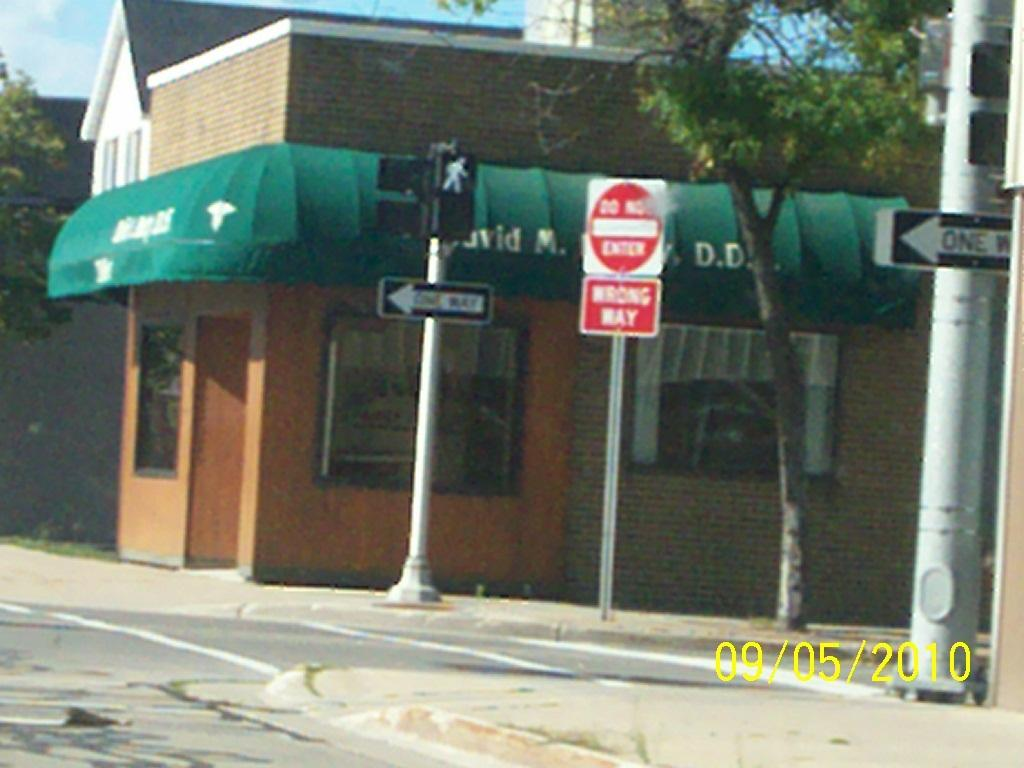What type of structures can be seen in the image? There are houses in the image. What feature is common to many of the houses in the image? There are windows in the image. What are the poles likely used for in the image? The poles are likely used for supporting signboards or other objects in the image. What type of information might be conveyed by the signboards in the image? The signboards in the image might convey information about businesses, directions, or other notices. What is written on the board with text in the image? The specific text on the board cannot be determined from the image. What type of vegetation is present in the image? There are trees in the image. What part of the natural environment is visible in the image? The sky is visible in the image. Can you see the judge's wrist in the image? There is no judge or wrist present in the image. How many men are visible in the image? The number of men cannot be determined from the image, as it does not show any people. 